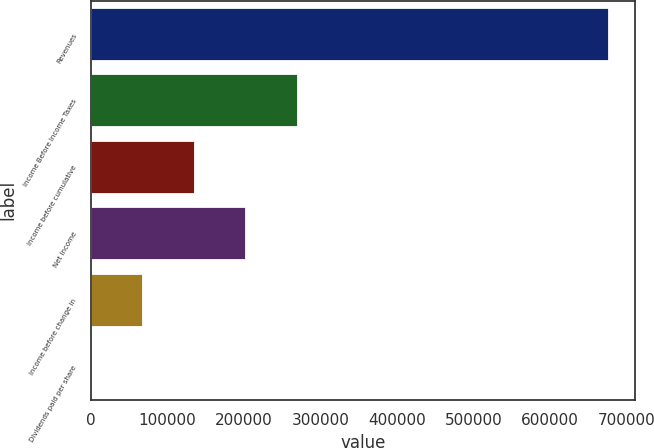Convert chart to OTSL. <chart><loc_0><loc_0><loc_500><loc_500><bar_chart><fcel>Revenues<fcel>Income Before Income Taxes<fcel>Income before cumulative<fcel>Net Income<fcel>Income before change in<fcel>Dividends paid per share<nl><fcel>677013<fcel>270805<fcel>135403<fcel>203104<fcel>67701.4<fcel>0.09<nl></chart> 